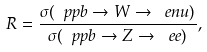Convert formula to latex. <formula><loc_0><loc_0><loc_500><loc_500>R = \frac { \sigma ( \ p p b \rightarrow W \rightarrow \ e n u ) } { \sigma ( \ p p b \rightarrow Z \rightarrow \ e e ) } , \\</formula> 